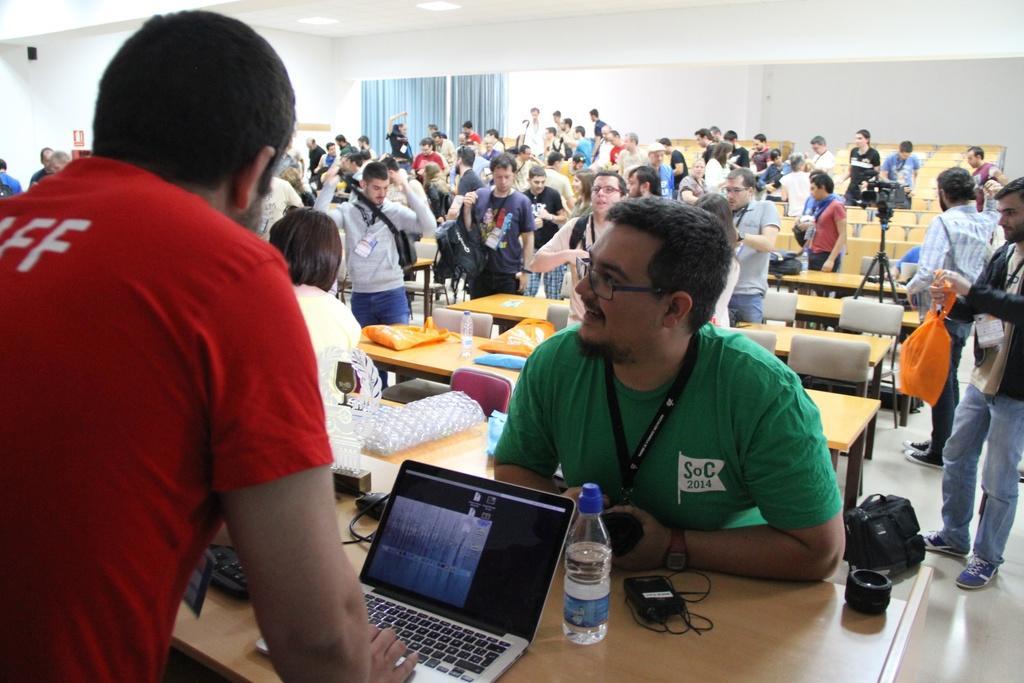How would you summarize this image in a sentence or two? In the image we can see group of persons were sitting and standing around the table. On table we can see plastic covers,books and water bottle. In the front we can see one man standing and working on laptop. In the background there is a wall,curtain etc. 